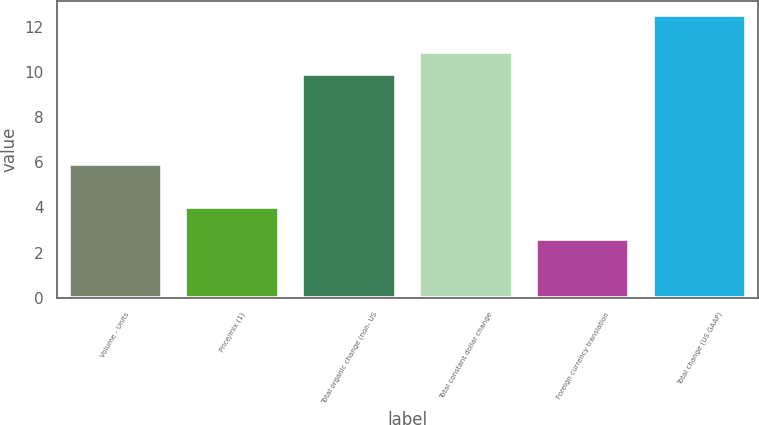Convert chart. <chart><loc_0><loc_0><loc_500><loc_500><bar_chart><fcel>Volume - Units<fcel>Price/mix (1)<fcel>Total organic change (non- US<fcel>Total constant dollar change<fcel>Foreign currency translation<fcel>Total change (US GAAP)<nl><fcel>5.9<fcel>4<fcel>9.9<fcel>10.89<fcel>2.6<fcel>12.5<nl></chart> 